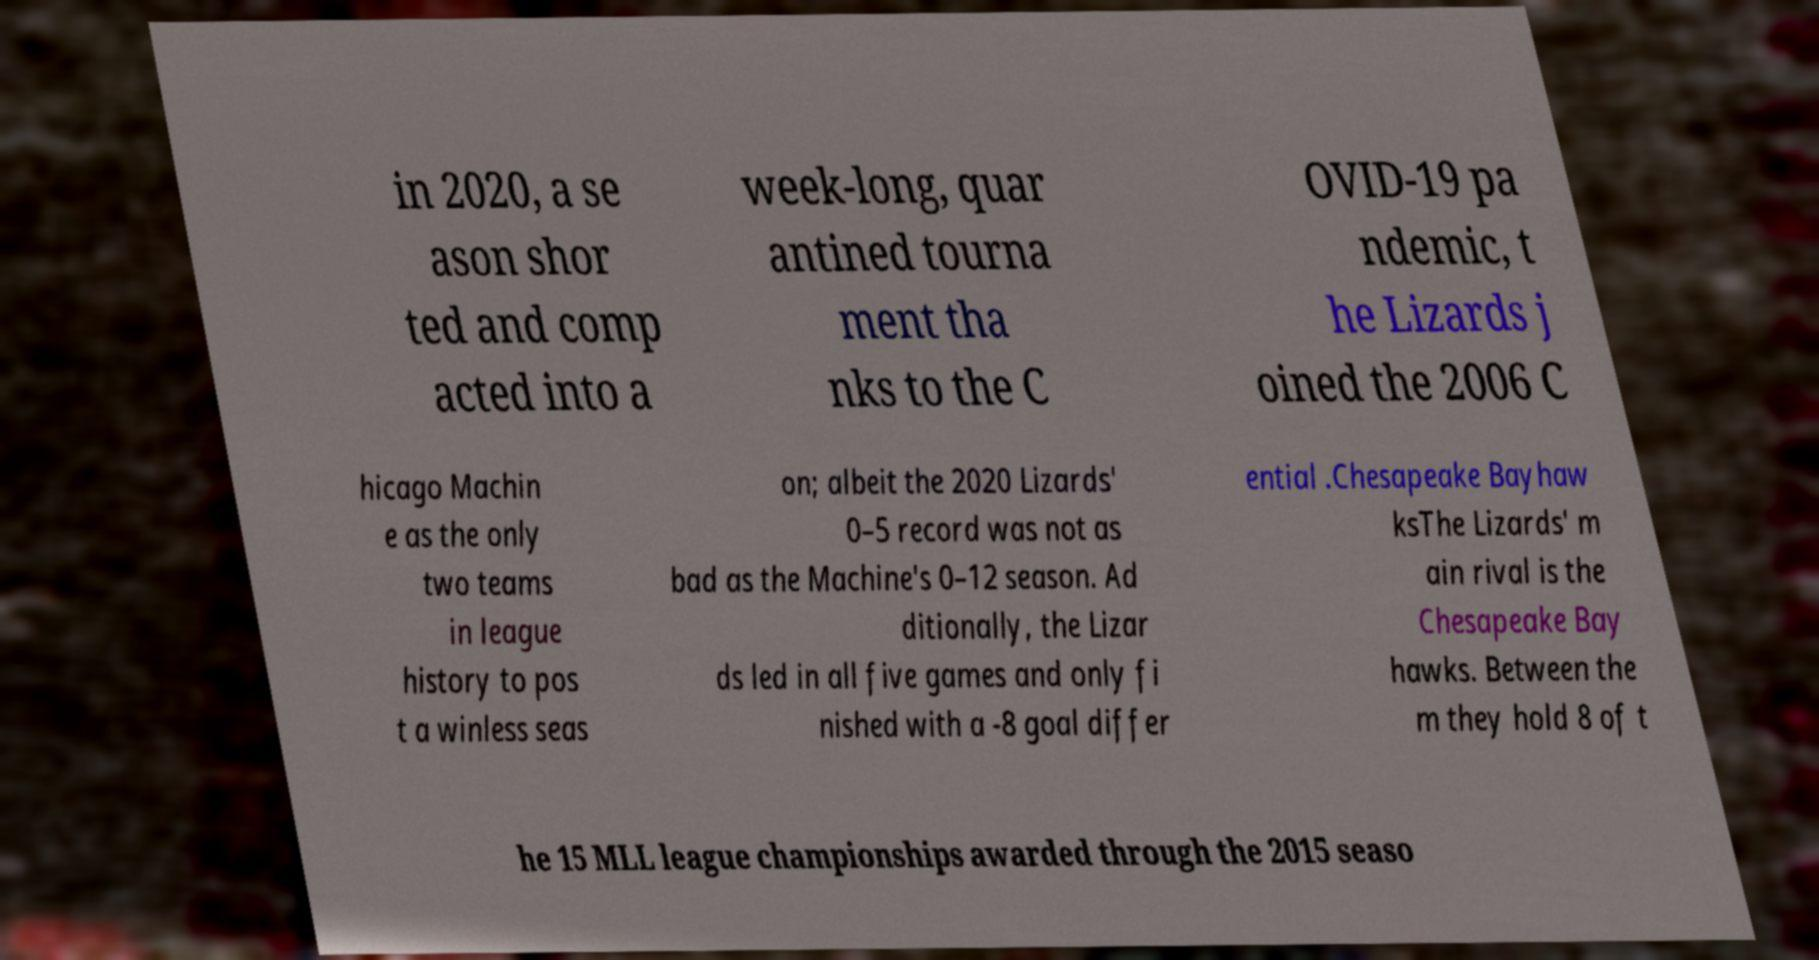Can you read and provide the text displayed in the image?This photo seems to have some interesting text. Can you extract and type it out for me? in 2020, a se ason shor ted and comp acted into a week-long, quar antined tourna ment tha nks to the C OVID-19 pa ndemic, t he Lizards j oined the 2006 C hicago Machin e as the only two teams in league history to pos t a winless seas on; albeit the 2020 Lizards' 0–5 record was not as bad as the Machine's 0–12 season. Ad ditionally, the Lizar ds led in all five games and only fi nished with a -8 goal differ ential .Chesapeake Bayhaw ksThe Lizards' m ain rival is the Chesapeake Bay hawks. Between the m they hold 8 of t he 15 MLL league championships awarded through the 2015 seaso 